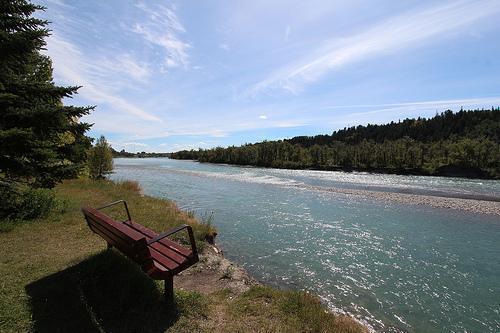How many benches?
Give a very brief answer. 1. How many shadows?
Give a very brief answer. 1. 